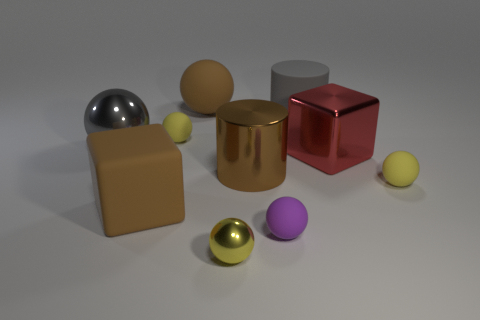Subtract all gray cubes. How many yellow balls are left? 3 Subtract all large brown rubber balls. How many balls are left? 5 Subtract all gray balls. How many balls are left? 5 Subtract all gray spheres. Subtract all blue cylinders. How many spheres are left? 5 Subtract all cubes. How many objects are left? 8 Subtract all small yellow matte things. Subtract all big shiny objects. How many objects are left? 5 Add 7 brown spheres. How many brown spheres are left? 8 Add 6 gray metal balls. How many gray metal balls exist? 7 Subtract 1 red cubes. How many objects are left? 9 